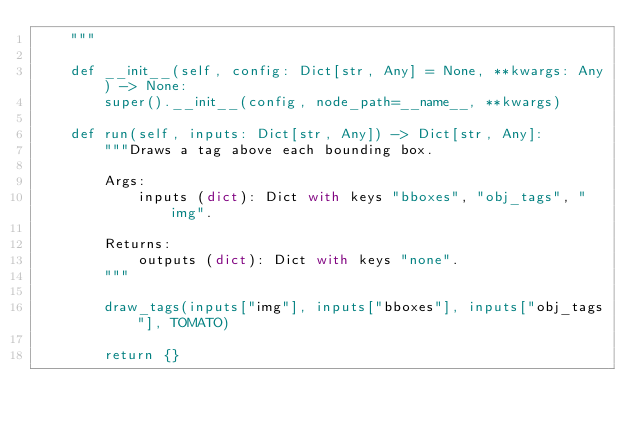Convert code to text. <code><loc_0><loc_0><loc_500><loc_500><_Python_>    """

    def __init__(self, config: Dict[str, Any] = None, **kwargs: Any) -> None:
        super().__init__(config, node_path=__name__, **kwargs)

    def run(self, inputs: Dict[str, Any]) -> Dict[str, Any]:
        """Draws a tag above each bounding box.

        Args:
            inputs (dict): Dict with keys "bboxes", "obj_tags", "img".

        Returns:
            outputs (dict): Dict with keys "none".
        """

        draw_tags(inputs["img"], inputs["bboxes"], inputs["obj_tags"], TOMATO)

        return {}
</code> 